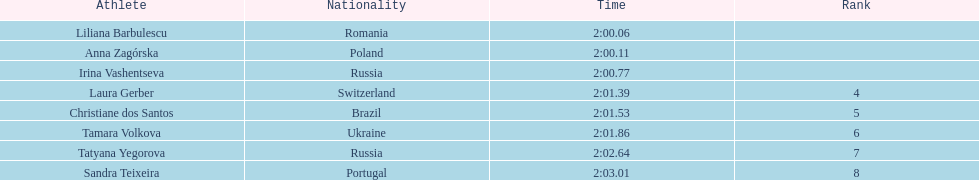In regards to anna zagorska, what was her finishing time? 2:00.11. 